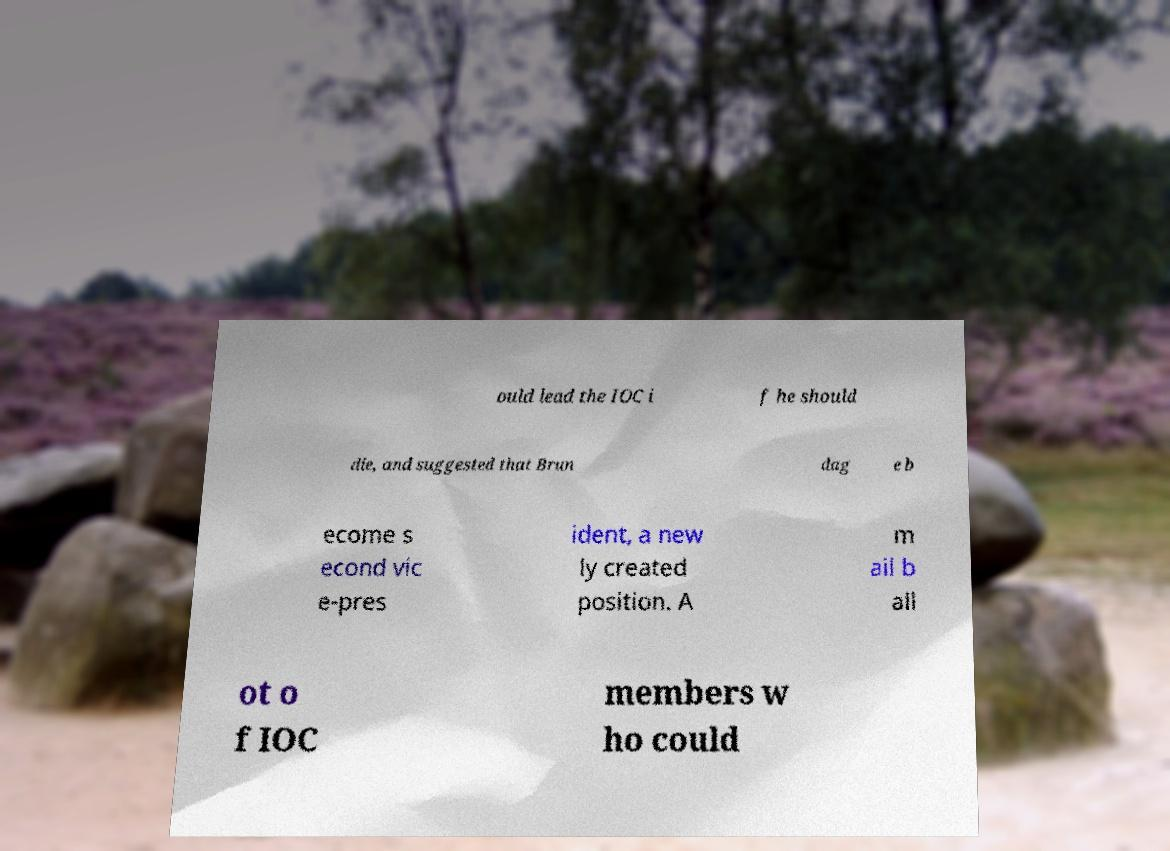Please read and relay the text visible in this image. What does it say? ould lead the IOC i f he should die, and suggested that Brun dag e b ecome s econd vic e-pres ident, a new ly created position. A m ail b all ot o f IOC members w ho could 